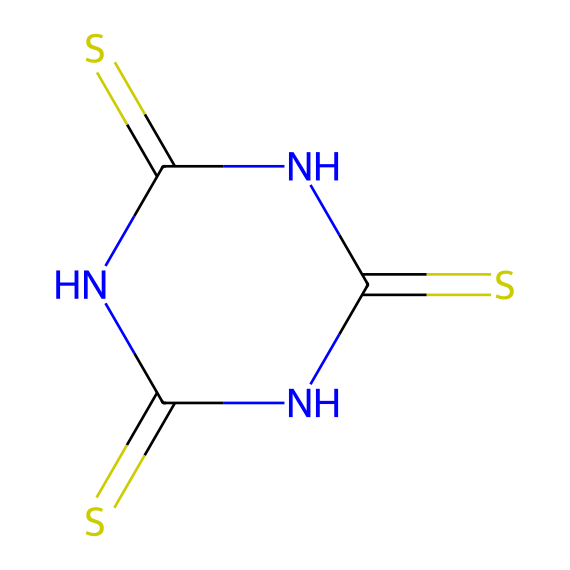What is the total number of nitrogen atoms in this compound? The structure reveals that there are two nitrogen atoms indicated by the 'N' in the SMILES.
Answer: 2 How many sulfur atoms are present in this chemical? The SMILES representation shows three sulfur atoms, each represented by the letter 'S'.
Answer: 3 What type of compound is represented by this SMILES notation? This SMILES includes sulfur and nitrogen, characteristic of organosulfur compounds.
Answer: organosulfur Can you identify the functional groups in this chemical structure? The compound contains thioamide groups due to the presence of the nitrogen atoms adjacent to sulfur and carbon, specifically NC(=S).
Answer: thioamide What is the degree of unsaturation for this chemical? The presence of double bonds in the thioamide leads to one degree of unsaturation for each double bond; thus, there are two double bonds present here.
Answer: 2 What is the chemical's potential application in electric vehicle components? Given the structure, this organosulfur compound may be utilized as a vulcanization agent for improving the durability of rubber.
Answer: vulcanization agent Which part of the structure indicates that sulfur is central to this compound? The presence of multiple sulfur atoms and their bonding arrangements highlight that sulfur plays a central role in its properties.
Answer: sulfur atoms 